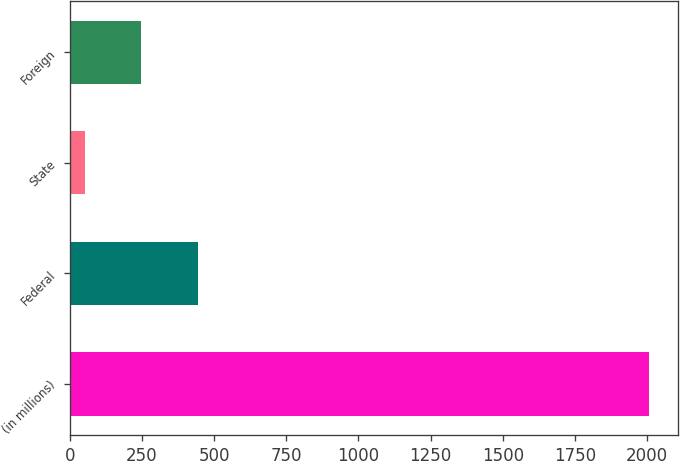<chart> <loc_0><loc_0><loc_500><loc_500><bar_chart><fcel>(in millions)<fcel>Federal<fcel>State<fcel>Foreign<nl><fcel>2006<fcel>443.6<fcel>53<fcel>248.3<nl></chart> 